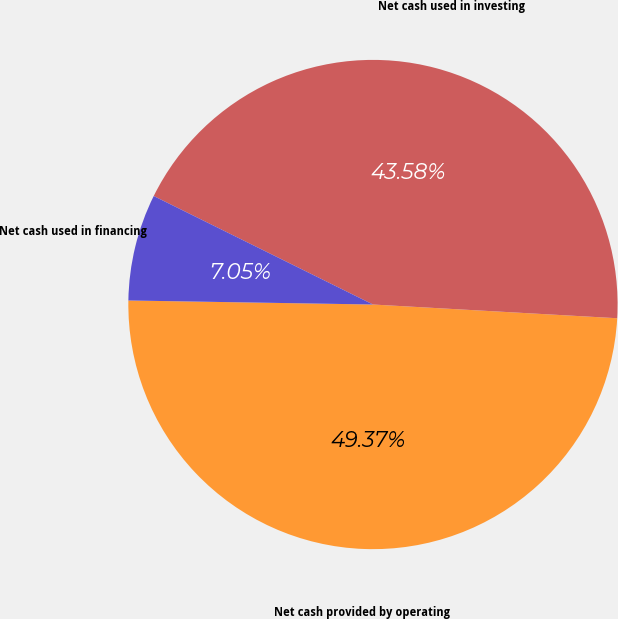Convert chart. <chart><loc_0><loc_0><loc_500><loc_500><pie_chart><fcel>Net cash provided by operating<fcel>Net cash used in investing<fcel>Net cash used in financing<nl><fcel>49.37%<fcel>43.58%<fcel>7.05%<nl></chart> 